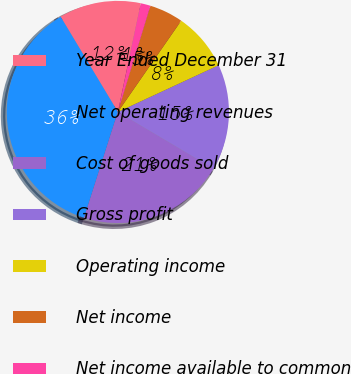<chart> <loc_0><loc_0><loc_500><loc_500><pie_chart><fcel>Year Ended December 31<fcel>Net operating revenues<fcel>Cost of goods sold<fcel>Gross profit<fcel>Operating income<fcel>Net income<fcel>Net income available to common<nl><fcel>11.93%<fcel>36.47%<fcel>21.39%<fcel>15.44%<fcel>8.43%<fcel>4.92%<fcel>1.42%<nl></chart> 